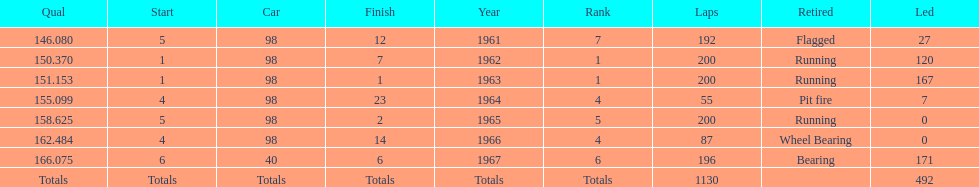Can you parse all the data within this table? {'header': ['Qual', 'Start', 'Car', 'Finish', 'Year', 'Rank', 'Laps', 'Retired', 'Led'], 'rows': [['146.080', '5', '98', '12', '1961', '7', '192', 'Flagged', '27'], ['150.370', '1', '98', '7', '1962', '1', '200', 'Running', '120'], ['151.153', '1', '98', '1', '1963', '1', '200', 'Running', '167'], ['155.099', '4', '98', '23', '1964', '4', '55', 'Pit fire', '7'], ['158.625', '5', '98', '2', '1965', '5', '200', 'Running', '0'], ['162.484', '4', '98', '14', '1966', '4', '87', 'Wheel Bearing', '0'], ['166.075', '6', '40', '6', '1967', '6', '196', 'Bearing', '171'], ['Totals', 'Totals', 'Totals', 'Totals', 'Totals', 'Totals', '1130', '', '492']]} What was his best finish before his first win? 7. 